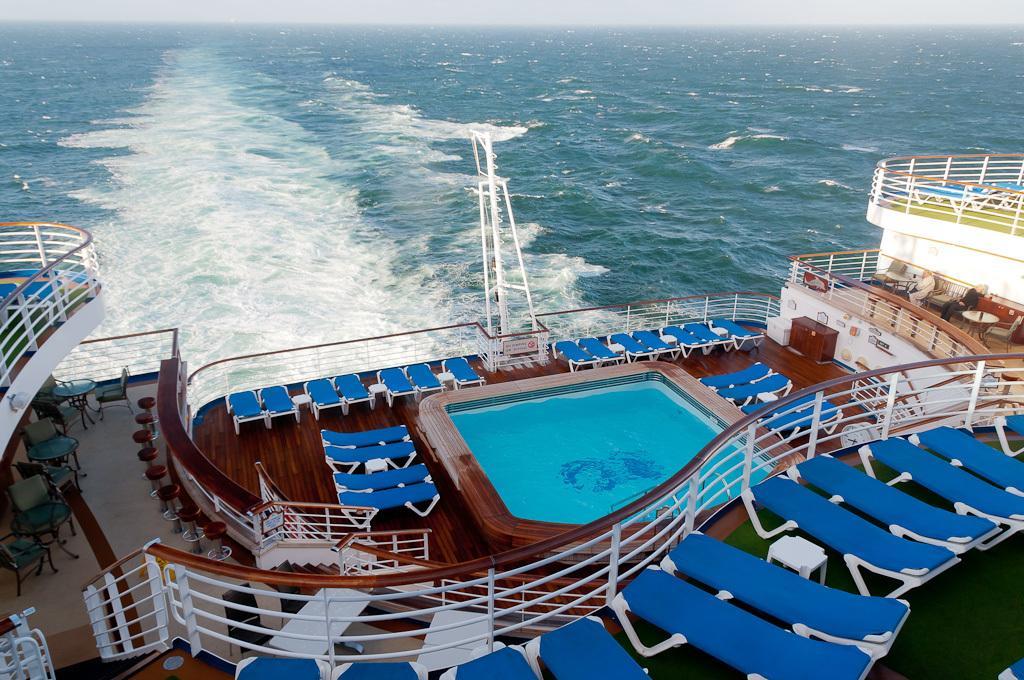How would you summarize this image in a sentence or two? In this image we can see a big ship where we can see chairs, tables, swimming pool and a person here. Here we can see wooden flooring and the pole. In the background, we can see the water and the sky. 